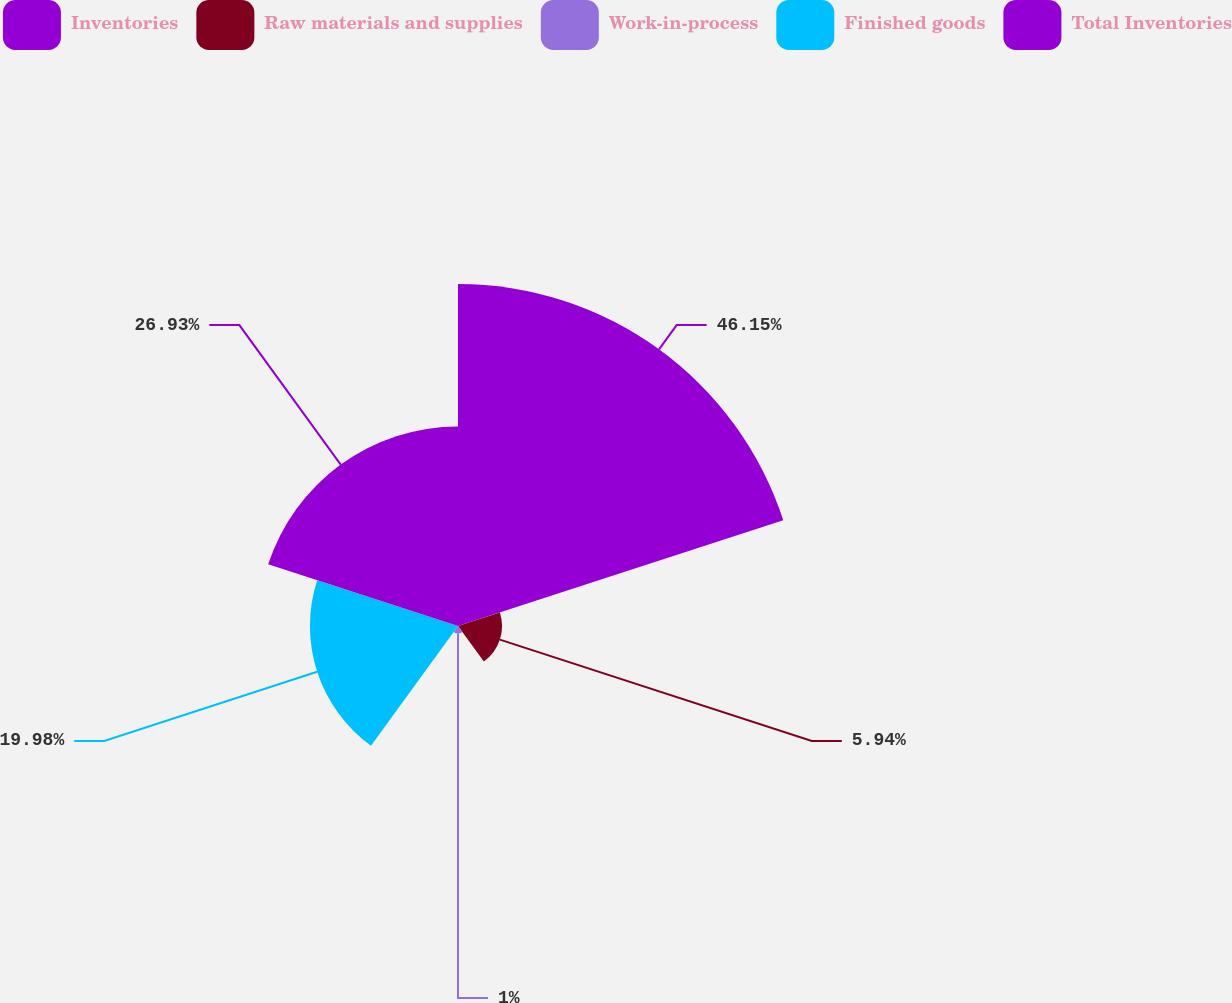Convert chart to OTSL. <chart><loc_0><loc_0><loc_500><loc_500><pie_chart><fcel>Inventories<fcel>Raw materials and supplies<fcel>Work-in-process<fcel>Finished goods<fcel>Total Inventories<nl><fcel>46.15%<fcel>5.94%<fcel>1.0%<fcel>19.98%<fcel>26.93%<nl></chart> 